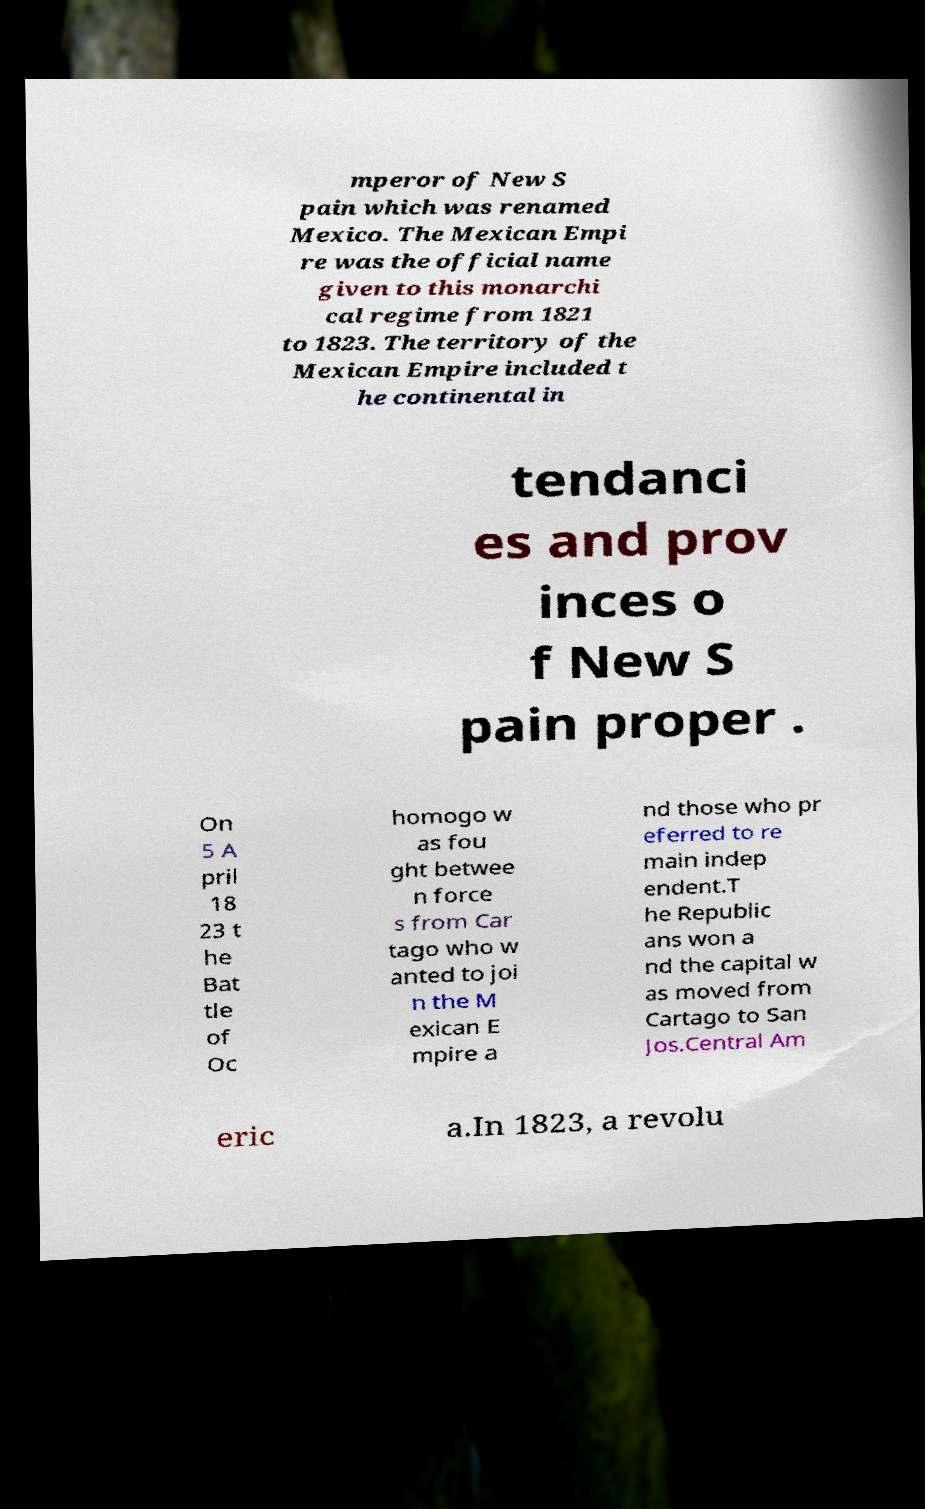Could you extract and type out the text from this image? mperor of New S pain which was renamed Mexico. The Mexican Empi re was the official name given to this monarchi cal regime from 1821 to 1823. The territory of the Mexican Empire included t he continental in tendanci es and prov inces o f New S pain proper . On 5 A pril 18 23 t he Bat tle of Oc homogo w as fou ght betwee n force s from Car tago who w anted to joi n the M exican E mpire a nd those who pr eferred to re main indep endent.T he Republic ans won a nd the capital w as moved from Cartago to San Jos.Central Am eric a.In 1823, a revolu 